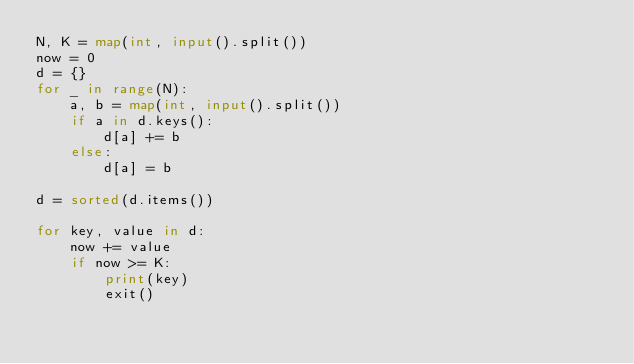<code> <loc_0><loc_0><loc_500><loc_500><_Python_>N, K = map(int, input().split())
now = 0
d = {}
for _ in range(N):
    a, b = map(int, input().split())
    if a in d.keys():
        d[a] += b
    else:
        d[a] = b

d = sorted(d.items())

for key, value in d:
    now += value
    if now >= K:
        print(key)
        exit()
</code> 